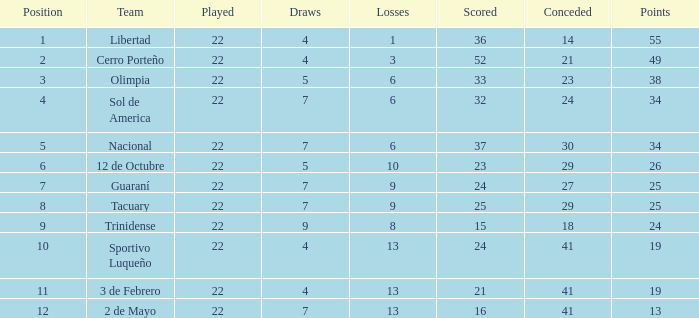What is the fewest wins that has fewer than 23 goals scored, team of 2 de Mayo, and fewer than 7 draws? None. 